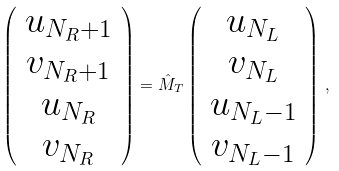Convert formula to latex. <formula><loc_0><loc_0><loc_500><loc_500>\left ( \begin{array} { c } u _ { N _ { R } + 1 } \\ v _ { N _ { R } + 1 } \\ u _ { N _ { R } } \\ v _ { N _ { R } } \end{array} \right ) = \hat { M } _ { T } \left ( \begin{array} { c } u _ { N _ { L } } \\ v _ { N _ { L } } \\ u _ { N _ { L } - 1 } \\ v _ { N _ { L } - 1 } \end{array} \right ) \, ,</formula> 